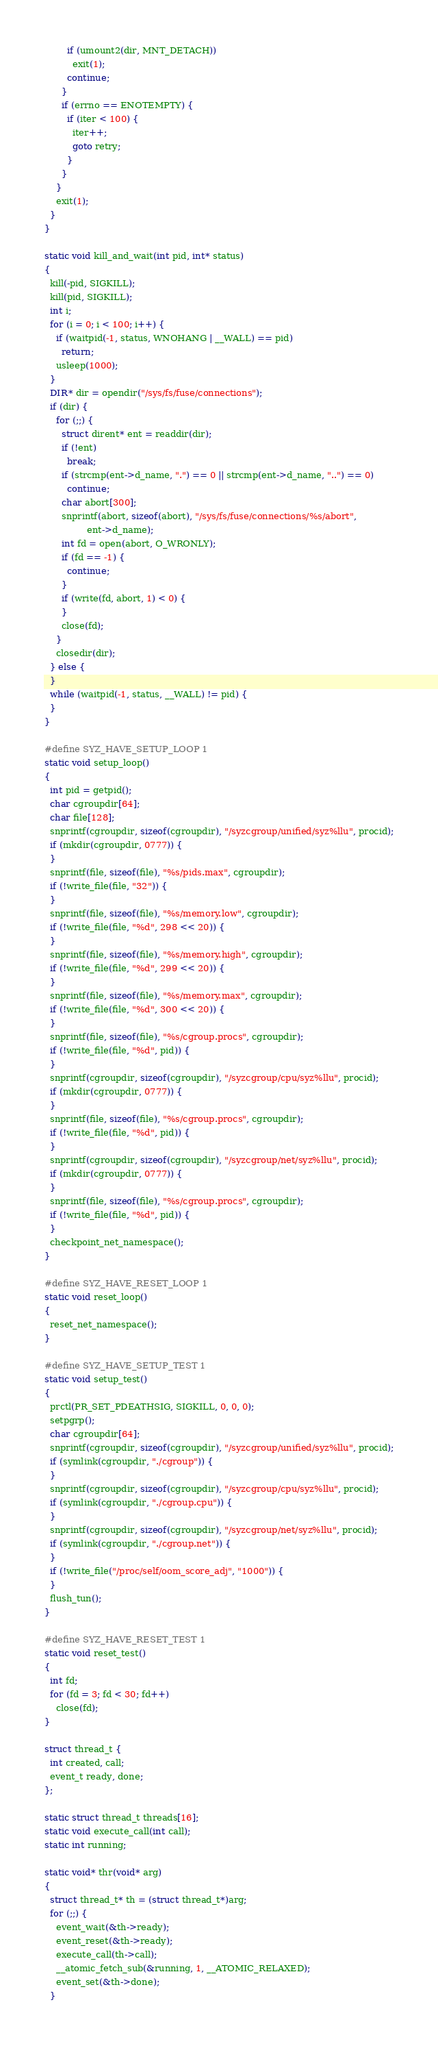Convert code to text. <code><loc_0><loc_0><loc_500><loc_500><_C_>        if (umount2(dir, MNT_DETACH))
          exit(1);
        continue;
      }
      if (errno == ENOTEMPTY) {
        if (iter < 100) {
          iter++;
          goto retry;
        }
      }
    }
    exit(1);
  }
}

static void kill_and_wait(int pid, int* status)
{
  kill(-pid, SIGKILL);
  kill(pid, SIGKILL);
  int i;
  for (i = 0; i < 100; i++) {
    if (waitpid(-1, status, WNOHANG | __WALL) == pid)
      return;
    usleep(1000);
  }
  DIR* dir = opendir("/sys/fs/fuse/connections");
  if (dir) {
    for (;;) {
      struct dirent* ent = readdir(dir);
      if (!ent)
        break;
      if (strcmp(ent->d_name, ".") == 0 || strcmp(ent->d_name, "..") == 0)
        continue;
      char abort[300];
      snprintf(abort, sizeof(abort), "/sys/fs/fuse/connections/%s/abort",
               ent->d_name);
      int fd = open(abort, O_WRONLY);
      if (fd == -1) {
        continue;
      }
      if (write(fd, abort, 1) < 0) {
      }
      close(fd);
    }
    closedir(dir);
  } else {
  }
  while (waitpid(-1, status, __WALL) != pid) {
  }
}

#define SYZ_HAVE_SETUP_LOOP 1
static void setup_loop()
{
  int pid = getpid();
  char cgroupdir[64];
  char file[128];
  snprintf(cgroupdir, sizeof(cgroupdir), "/syzcgroup/unified/syz%llu", procid);
  if (mkdir(cgroupdir, 0777)) {
  }
  snprintf(file, sizeof(file), "%s/pids.max", cgroupdir);
  if (!write_file(file, "32")) {
  }
  snprintf(file, sizeof(file), "%s/memory.low", cgroupdir);
  if (!write_file(file, "%d", 298 << 20)) {
  }
  snprintf(file, sizeof(file), "%s/memory.high", cgroupdir);
  if (!write_file(file, "%d", 299 << 20)) {
  }
  snprintf(file, sizeof(file), "%s/memory.max", cgroupdir);
  if (!write_file(file, "%d", 300 << 20)) {
  }
  snprintf(file, sizeof(file), "%s/cgroup.procs", cgroupdir);
  if (!write_file(file, "%d", pid)) {
  }
  snprintf(cgroupdir, sizeof(cgroupdir), "/syzcgroup/cpu/syz%llu", procid);
  if (mkdir(cgroupdir, 0777)) {
  }
  snprintf(file, sizeof(file), "%s/cgroup.procs", cgroupdir);
  if (!write_file(file, "%d", pid)) {
  }
  snprintf(cgroupdir, sizeof(cgroupdir), "/syzcgroup/net/syz%llu", procid);
  if (mkdir(cgroupdir, 0777)) {
  }
  snprintf(file, sizeof(file), "%s/cgroup.procs", cgroupdir);
  if (!write_file(file, "%d", pid)) {
  }
  checkpoint_net_namespace();
}

#define SYZ_HAVE_RESET_LOOP 1
static void reset_loop()
{
  reset_net_namespace();
}

#define SYZ_HAVE_SETUP_TEST 1
static void setup_test()
{
  prctl(PR_SET_PDEATHSIG, SIGKILL, 0, 0, 0);
  setpgrp();
  char cgroupdir[64];
  snprintf(cgroupdir, sizeof(cgroupdir), "/syzcgroup/unified/syz%llu", procid);
  if (symlink(cgroupdir, "./cgroup")) {
  }
  snprintf(cgroupdir, sizeof(cgroupdir), "/syzcgroup/cpu/syz%llu", procid);
  if (symlink(cgroupdir, "./cgroup.cpu")) {
  }
  snprintf(cgroupdir, sizeof(cgroupdir), "/syzcgroup/net/syz%llu", procid);
  if (symlink(cgroupdir, "./cgroup.net")) {
  }
  if (!write_file("/proc/self/oom_score_adj", "1000")) {
  }
  flush_tun();
}

#define SYZ_HAVE_RESET_TEST 1
static void reset_test()
{
  int fd;
  for (fd = 3; fd < 30; fd++)
    close(fd);
}

struct thread_t {
  int created, call;
  event_t ready, done;
};

static struct thread_t threads[16];
static void execute_call(int call);
static int running;

static void* thr(void* arg)
{
  struct thread_t* th = (struct thread_t*)arg;
  for (;;) {
    event_wait(&th->ready);
    event_reset(&th->ready);
    execute_call(th->call);
    __atomic_fetch_sub(&running, 1, __ATOMIC_RELAXED);
    event_set(&th->done);
  }</code> 